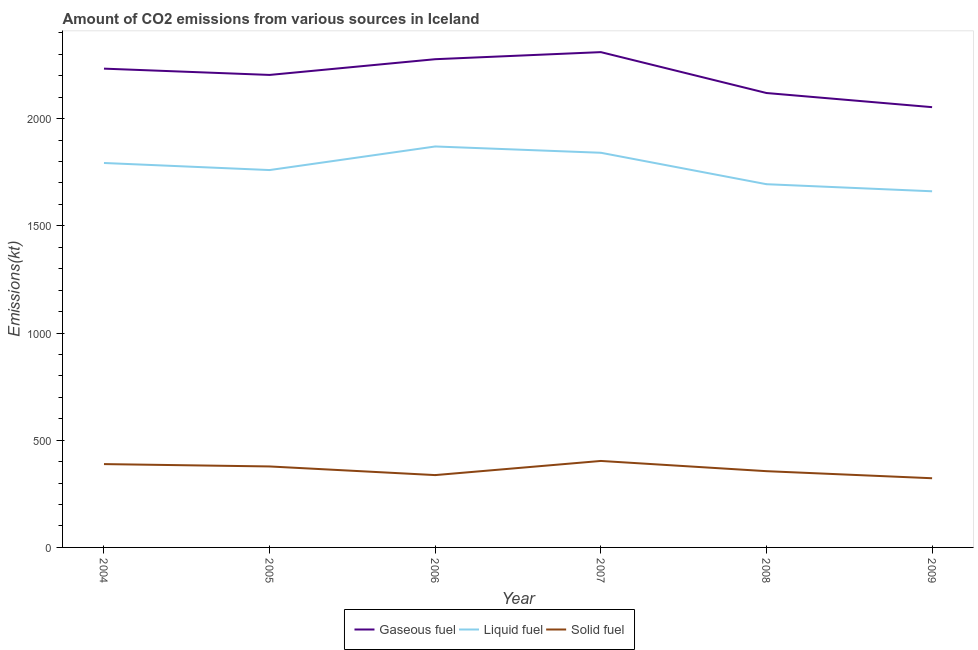What is the amount of co2 emissions from liquid fuel in 2004?
Keep it short and to the point. 1793.16. Across all years, what is the maximum amount of co2 emissions from solid fuel?
Provide a short and direct response. 403.37. Across all years, what is the minimum amount of co2 emissions from liquid fuel?
Ensure brevity in your answer.  1661.15. What is the total amount of co2 emissions from gaseous fuel in the graph?
Your response must be concise. 1.32e+04. What is the difference between the amount of co2 emissions from solid fuel in 2005 and that in 2007?
Keep it short and to the point. -25.67. What is the difference between the amount of co2 emissions from liquid fuel in 2007 and the amount of co2 emissions from gaseous fuel in 2006?
Keep it short and to the point. -436.37. What is the average amount of co2 emissions from solid fuel per year?
Your answer should be compact. 364.26. In the year 2005, what is the difference between the amount of co2 emissions from gaseous fuel and amount of co2 emissions from solid fuel?
Your answer should be compact. 1826.17. In how many years, is the amount of co2 emissions from solid fuel greater than 1600 kt?
Offer a terse response. 0. What is the ratio of the amount of co2 emissions from gaseous fuel in 2006 to that in 2009?
Provide a succinct answer. 1.11. Is the amount of co2 emissions from liquid fuel in 2005 less than that in 2009?
Your response must be concise. No. What is the difference between the highest and the second highest amount of co2 emissions from gaseous fuel?
Make the answer very short. 33. What is the difference between the highest and the lowest amount of co2 emissions from liquid fuel?
Provide a short and direct response. 209.02. In how many years, is the amount of co2 emissions from gaseous fuel greater than the average amount of co2 emissions from gaseous fuel taken over all years?
Your answer should be very brief. 4. Is it the case that in every year, the sum of the amount of co2 emissions from gaseous fuel and amount of co2 emissions from liquid fuel is greater than the amount of co2 emissions from solid fuel?
Provide a succinct answer. Yes. Is the amount of co2 emissions from liquid fuel strictly greater than the amount of co2 emissions from solid fuel over the years?
Offer a terse response. Yes. How many lines are there?
Keep it short and to the point. 3. How many years are there in the graph?
Keep it short and to the point. 6. What is the difference between two consecutive major ticks on the Y-axis?
Give a very brief answer. 500. Are the values on the major ticks of Y-axis written in scientific E-notation?
Give a very brief answer. No. Does the graph contain any zero values?
Keep it short and to the point. No. Where does the legend appear in the graph?
Keep it short and to the point. Bottom center. How many legend labels are there?
Your answer should be compact. 3. What is the title of the graph?
Ensure brevity in your answer.  Amount of CO2 emissions from various sources in Iceland. What is the label or title of the X-axis?
Your response must be concise. Year. What is the label or title of the Y-axis?
Keep it short and to the point. Emissions(kt). What is the Emissions(kt) of Gaseous fuel in 2004?
Give a very brief answer. 2233.2. What is the Emissions(kt) in Liquid fuel in 2004?
Your response must be concise. 1793.16. What is the Emissions(kt) in Solid fuel in 2004?
Make the answer very short. 388.7. What is the Emissions(kt) of Gaseous fuel in 2005?
Your answer should be very brief. 2203.87. What is the Emissions(kt) in Liquid fuel in 2005?
Your response must be concise. 1760.16. What is the Emissions(kt) in Solid fuel in 2005?
Give a very brief answer. 377.7. What is the Emissions(kt) of Gaseous fuel in 2006?
Make the answer very short. 2277.21. What is the Emissions(kt) of Liquid fuel in 2006?
Your response must be concise. 1870.17. What is the Emissions(kt) in Solid fuel in 2006?
Give a very brief answer. 337.36. What is the Emissions(kt) of Gaseous fuel in 2007?
Ensure brevity in your answer.  2310.21. What is the Emissions(kt) of Liquid fuel in 2007?
Give a very brief answer. 1840.83. What is the Emissions(kt) of Solid fuel in 2007?
Make the answer very short. 403.37. What is the Emissions(kt) of Gaseous fuel in 2008?
Your answer should be compact. 2119.53. What is the Emissions(kt) in Liquid fuel in 2008?
Provide a succinct answer. 1694.15. What is the Emissions(kt) in Solid fuel in 2008?
Ensure brevity in your answer.  355.7. What is the Emissions(kt) of Gaseous fuel in 2009?
Make the answer very short. 2053.52. What is the Emissions(kt) of Liquid fuel in 2009?
Offer a very short reply. 1661.15. What is the Emissions(kt) of Solid fuel in 2009?
Make the answer very short. 322.7. Across all years, what is the maximum Emissions(kt) in Gaseous fuel?
Your answer should be very brief. 2310.21. Across all years, what is the maximum Emissions(kt) in Liquid fuel?
Offer a terse response. 1870.17. Across all years, what is the maximum Emissions(kt) of Solid fuel?
Offer a very short reply. 403.37. Across all years, what is the minimum Emissions(kt) of Gaseous fuel?
Make the answer very short. 2053.52. Across all years, what is the minimum Emissions(kt) of Liquid fuel?
Your answer should be compact. 1661.15. Across all years, what is the minimum Emissions(kt) of Solid fuel?
Your answer should be compact. 322.7. What is the total Emissions(kt) in Gaseous fuel in the graph?
Offer a very short reply. 1.32e+04. What is the total Emissions(kt) of Liquid fuel in the graph?
Your response must be concise. 1.06e+04. What is the total Emissions(kt) in Solid fuel in the graph?
Your answer should be compact. 2185.53. What is the difference between the Emissions(kt) in Gaseous fuel in 2004 and that in 2005?
Ensure brevity in your answer.  29.34. What is the difference between the Emissions(kt) in Liquid fuel in 2004 and that in 2005?
Your answer should be very brief. 33. What is the difference between the Emissions(kt) of Solid fuel in 2004 and that in 2005?
Provide a short and direct response. 11. What is the difference between the Emissions(kt) of Gaseous fuel in 2004 and that in 2006?
Provide a succinct answer. -44. What is the difference between the Emissions(kt) in Liquid fuel in 2004 and that in 2006?
Your answer should be compact. -77.01. What is the difference between the Emissions(kt) of Solid fuel in 2004 and that in 2006?
Your answer should be very brief. 51.34. What is the difference between the Emissions(kt) in Gaseous fuel in 2004 and that in 2007?
Provide a succinct answer. -77.01. What is the difference between the Emissions(kt) in Liquid fuel in 2004 and that in 2007?
Provide a succinct answer. -47.67. What is the difference between the Emissions(kt) in Solid fuel in 2004 and that in 2007?
Your answer should be compact. -14.67. What is the difference between the Emissions(kt) in Gaseous fuel in 2004 and that in 2008?
Keep it short and to the point. 113.68. What is the difference between the Emissions(kt) in Liquid fuel in 2004 and that in 2008?
Give a very brief answer. 99.01. What is the difference between the Emissions(kt) in Solid fuel in 2004 and that in 2008?
Make the answer very short. 33. What is the difference between the Emissions(kt) of Gaseous fuel in 2004 and that in 2009?
Offer a very short reply. 179.68. What is the difference between the Emissions(kt) of Liquid fuel in 2004 and that in 2009?
Offer a very short reply. 132.01. What is the difference between the Emissions(kt) of Solid fuel in 2004 and that in 2009?
Keep it short and to the point. 66.01. What is the difference between the Emissions(kt) of Gaseous fuel in 2005 and that in 2006?
Your answer should be compact. -73.34. What is the difference between the Emissions(kt) in Liquid fuel in 2005 and that in 2006?
Offer a terse response. -110.01. What is the difference between the Emissions(kt) of Solid fuel in 2005 and that in 2006?
Your response must be concise. 40.34. What is the difference between the Emissions(kt) of Gaseous fuel in 2005 and that in 2007?
Offer a very short reply. -106.34. What is the difference between the Emissions(kt) of Liquid fuel in 2005 and that in 2007?
Your answer should be compact. -80.67. What is the difference between the Emissions(kt) in Solid fuel in 2005 and that in 2007?
Provide a succinct answer. -25.67. What is the difference between the Emissions(kt) of Gaseous fuel in 2005 and that in 2008?
Your response must be concise. 84.34. What is the difference between the Emissions(kt) in Liquid fuel in 2005 and that in 2008?
Ensure brevity in your answer.  66.01. What is the difference between the Emissions(kt) in Solid fuel in 2005 and that in 2008?
Your answer should be compact. 22. What is the difference between the Emissions(kt) of Gaseous fuel in 2005 and that in 2009?
Offer a terse response. 150.35. What is the difference between the Emissions(kt) of Liquid fuel in 2005 and that in 2009?
Offer a terse response. 99.01. What is the difference between the Emissions(kt) of Solid fuel in 2005 and that in 2009?
Offer a very short reply. 55.01. What is the difference between the Emissions(kt) of Gaseous fuel in 2006 and that in 2007?
Your answer should be very brief. -33. What is the difference between the Emissions(kt) of Liquid fuel in 2006 and that in 2007?
Your answer should be compact. 29.34. What is the difference between the Emissions(kt) of Solid fuel in 2006 and that in 2007?
Provide a succinct answer. -66.01. What is the difference between the Emissions(kt) of Gaseous fuel in 2006 and that in 2008?
Offer a terse response. 157.68. What is the difference between the Emissions(kt) in Liquid fuel in 2006 and that in 2008?
Provide a succinct answer. 176.02. What is the difference between the Emissions(kt) in Solid fuel in 2006 and that in 2008?
Provide a succinct answer. -18.34. What is the difference between the Emissions(kt) of Gaseous fuel in 2006 and that in 2009?
Offer a terse response. 223.69. What is the difference between the Emissions(kt) in Liquid fuel in 2006 and that in 2009?
Offer a terse response. 209.02. What is the difference between the Emissions(kt) in Solid fuel in 2006 and that in 2009?
Provide a succinct answer. 14.67. What is the difference between the Emissions(kt) in Gaseous fuel in 2007 and that in 2008?
Ensure brevity in your answer.  190.68. What is the difference between the Emissions(kt) of Liquid fuel in 2007 and that in 2008?
Your answer should be compact. 146.68. What is the difference between the Emissions(kt) in Solid fuel in 2007 and that in 2008?
Make the answer very short. 47.67. What is the difference between the Emissions(kt) in Gaseous fuel in 2007 and that in 2009?
Offer a terse response. 256.69. What is the difference between the Emissions(kt) of Liquid fuel in 2007 and that in 2009?
Provide a succinct answer. 179.68. What is the difference between the Emissions(kt) in Solid fuel in 2007 and that in 2009?
Make the answer very short. 80.67. What is the difference between the Emissions(kt) of Gaseous fuel in 2008 and that in 2009?
Your answer should be very brief. 66.01. What is the difference between the Emissions(kt) of Liquid fuel in 2008 and that in 2009?
Keep it short and to the point. 33. What is the difference between the Emissions(kt) in Solid fuel in 2008 and that in 2009?
Offer a very short reply. 33. What is the difference between the Emissions(kt) in Gaseous fuel in 2004 and the Emissions(kt) in Liquid fuel in 2005?
Ensure brevity in your answer.  473.04. What is the difference between the Emissions(kt) in Gaseous fuel in 2004 and the Emissions(kt) in Solid fuel in 2005?
Offer a terse response. 1855.5. What is the difference between the Emissions(kt) in Liquid fuel in 2004 and the Emissions(kt) in Solid fuel in 2005?
Provide a succinct answer. 1415.46. What is the difference between the Emissions(kt) of Gaseous fuel in 2004 and the Emissions(kt) of Liquid fuel in 2006?
Your answer should be very brief. 363.03. What is the difference between the Emissions(kt) in Gaseous fuel in 2004 and the Emissions(kt) in Solid fuel in 2006?
Your answer should be very brief. 1895.84. What is the difference between the Emissions(kt) in Liquid fuel in 2004 and the Emissions(kt) in Solid fuel in 2006?
Make the answer very short. 1455.8. What is the difference between the Emissions(kt) in Gaseous fuel in 2004 and the Emissions(kt) in Liquid fuel in 2007?
Keep it short and to the point. 392.37. What is the difference between the Emissions(kt) of Gaseous fuel in 2004 and the Emissions(kt) of Solid fuel in 2007?
Your answer should be compact. 1829.83. What is the difference between the Emissions(kt) in Liquid fuel in 2004 and the Emissions(kt) in Solid fuel in 2007?
Your response must be concise. 1389.79. What is the difference between the Emissions(kt) of Gaseous fuel in 2004 and the Emissions(kt) of Liquid fuel in 2008?
Your answer should be very brief. 539.05. What is the difference between the Emissions(kt) of Gaseous fuel in 2004 and the Emissions(kt) of Solid fuel in 2008?
Provide a succinct answer. 1877.5. What is the difference between the Emissions(kt) in Liquid fuel in 2004 and the Emissions(kt) in Solid fuel in 2008?
Offer a terse response. 1437.46. What is the difference between the Emissions(kt) in Gaseous fuel in 2004 and the Emissions(kt) in Liquid fuel in 2009?
Offer a very short reply. 572.05. What is the difference between the Emissions(kt) in Gaseous fuel in 2004 and the Emissions(kt) in Solid fuel in 2009?
Your response must be concise. 1910.51. What is the difference between the Emissions(kt) in Liquid fuel in 2004 and the Emissions(kt) in Solid fuel in 2009?
Offer a very short reply. 1470.47. What is the difference between the Emissions(kt) in Gaseous fuel in 2005 and the Emissions(kt) in Liquid fuel in 2006?
Your answer should be compact. 333.7. What is the difference between the Emissions(kt) of Gaseous fuel in 2005 and the Emissions(kt) of Solid fuel in 2006?
Give a very brief answer. 1866.5. What is the difference between the Emissions(kt) in Liquid fuel in 2005 and the Emissions(kt) in Solid fuel in 2006?
Your answer should be very brief. 1422.8. What is the difference between the Emissions(kt) of Gaseous fuel in 2005 and the Emissions(kt) of Liquid fuel in 2007?
Your response must be concise. 363.03. What is the difference between the Emissions(kt) of Gaseous fuel in 2005 and the Emissions(kt) of Solid fuel in 2007?
Provide a succinct answer. 1800.5. What is the difference between the Emissions(kt) in Liquid fuel in 2005 and the Emissions(kt) in Solid fuel in 2007?
Ensure brevity in your answer.  1356.79. What is the difference between the Emissions(kt) of Gaseous fuel in 2005 and the Emissions(kt) of Liquid fuel in 2008?
Your answer should be very brief. 509.71. What is the difference between the Emissions(kt) in Gaseous fuel in 2005 and the Emissions(kt) in Solid fuel in 2008?
Keep it short and to the point. 1848.17. What is the difference between the Emissions(kt) of Liquid fuel in 2005 and the Emissions(kt) of Solid fuel in 2008?
Your answer should be very brief. 1404.46. What is the difference between the Emissions(kt) of Gaseous fuel in 2005 and the Emissions(kt) of Liquid fuel in 2009?
Offer a terse response. 542.72. What is the difference between the Emissions(kt) of Gaseous fuel in 2005 and the Emissions(kt) of Solid fuel in 2009?
Ensure brevity in your answer.  1881.17. What is the difference between the Emissions(kt) in Liquid fuel in 2005 and the Emissions(kt) in Solid fuel in 2009?
Provide a short and direct response. 1437.46. What is the difference between the Emissions(kt) of Gaseous fuel in 2006 and the Emissions(kt) of Liquid fuel in 2007?
Offer a terse response. 436.37. What is the difference between the Emissions(kt) of Gaseous fuel in 2006 and the Emissions(kt) of Solid fuel in 2007?
Give a very brief answer. 1873.84. What is the difference between the Emissions(kt) in Liquid fuel in 2006 and the Emissions(kt) in Solid fuel in 2007?
Your response must be concise. 1466.8. What is the difference between the Emissions(kt) in Gaseous fuel in 2006 and the Emissions(kt) in Liquid fuel in 2008?
Give a very brief answer. 583.05. What is the difference between the Emissions(kt) of Gaseous fuel in 2006 and the Emissions(kt) of Solid fuel in 2008?
Give a very brief answer. 1921.51. What is the difference between the Emissions(kt) of Liquid fuel in 2006 and the Emissions(kt) of Solid fuel in 2008?
Your answer should be very brief. 1514.47. What is the difference between the Emissions(kt) in Gaseous fuel in 2006 and the Emissions(kt) in Liquid fuel in 2009?
Make the answer very short. 616.06. What is the difference between the Emissions(kt) in Gaseous fuel in 2006 and the Emissions(kt) in Solid fuel in 2009?
Your response must be concise. 1954.51. What is the difference between the Emissions(kt) in Liquid fuel in 2006 and the Emissions(kt) in Solid fuel in 2009?
Your answer should be compact. 1547.47. What is the difference between the Emissions(kt) in Gaseous fuel in 2007 and the Emissions(kt) in Liquid fuel in 2008?
Keep it short and to the point. 616.06. What is the difference between the Emissions(kt) in Gaseous fuel in 2007 and the Emissions(kt) in Solid fuel in 2008?
Provide a short and direct response. 1954.51. What is the difference between the Emissions(kt) in Liquid fuel in 2007 and the Emissions(kt) in Solid fuel in 2008?
Offer a very short reply. 1485.13. What is the difference between the Emissions(kt) of Gaseous fuel in 2007 and the Emissions(kt) of Liquid fuel in 2009?
Make the answer very short. 649.06. What is the difference between the Emissions(kt) in Gaseous fuel in 2007 and the Emissions(kt) in Solid fuel in 2009?
Provide a short and direct response. 1987.51. What is the difference between the Emissions(kt) in Liquid fuel in 2007 and the Emissions(kt) in Solid fuel in 2009?
Ensure brevity in your answer.  1518.14. What is the difference between the Emissions(kt) of Gaseous fuel in 2008 and the Emissions(kt) of Liquid fuel in 2009?
Provide a succinct answer. 458.38. What is the difference between the Emissions(kt) in Gaseous fuel in 2008 and the Emissions(kt) in Solid fuel in 2009?
Ensure brevity in your answer.  1796.83. What is the difference between the Emissions(kt) of Liquid fuel in 2008 and the Emissions(kt) of Solid fuel in 2009?
Your answer should be compact. 1371.46. What is the average Emissions(kt) in Gaseous fuel per year?
Your answer should be compact. 2199.59. What is the average Emissions(kt) of Liquid fuel per year?
Your answer should be very brief. 1769.94. What is the average Emissions(kt) in Solid fuel per year?
Offer a very short reply. 364.26. In the year 2004, what is the difference between the Emissions(kt) in Gaseous fuel and Emissions(kt) in Liquid fuel?
Make the answer very short. 440.04. In the year 2004, what is the difference between the Emissions(kt) in Gaseous fuel and Emissions(kt) in Solid fuel?
Your response must be concise. 1844.5. In the year 2004, what is the difference between the Emissions(kt) of Liquid fuel and Emissions(kt) of Solid fuel?
Give a very brief answer. 1404.46. In the year 2005, what is the difference between the Emissions(kt) of Gaseous fuel and Emissions(kt) of Liquid fuel?
Give a very brief answer. 443.71. In the year 2005, what is the difference between the Emissions(kt) in Gaseous fuel and Emissions(kt) in Solid fuel?
Your answer should be compact. 1826.17. In the year 2005, what is the difference between the Emissions(kt) of Liquid fuel and Emissions(kt) of Solid fuel?
Your answer should be compact. 1382.46. In the year 2006, what is the difference between the Emissions(kt) of Gaseous fuel and Emissions(kt) of Liquid fuel?
Make the answer very short. 407.04. In the year 2006, what is the difference between the Emissions(kt) of Gaseous fuel and Emissions(kt) of Solid fuel?
Your answer should be very brief. 1939.84. In the year 2006, what is the difference between the Emissions(kt) of Liquid fuel and Emissions(kt) of Solid fuel?
Give a very brief answer. 1532.81. In the year 2007, what is the difference between the Emissions(kt) in Gaseous fuel and Emissions(kt) in Liquid fuel?
Keep it short and to the point. 469.38. In the year 2007, what is the difference between the Emissions(kt) of Gaseous fuel and Emissions(kt) of Solid fuel?
Your answer should be very brief. 1906.84. In the year 2007, what is the difference between the Emissions(kt) of Liquid fuel and Emissions(kt) of Solid fuel?
Your response must be concise. 1437.46. In the year 2008, what is the difference between the Emissions(kt) in Gaseous fuel and Emissions(kt) in Liquid fuel?
Your answer should be very brief. 425.37. In the year 2008, what is the difference between the Emissions(kt) of Gaseous fuel and Emissions(kt) of Solid fuel?
Offer a terse response. 1763.83. In the year 2008, what is the difference between the Emissions(kt) of Liquid fuel and Emissions(kt) of Solid fuel?
Your response must be concise. 1338.45. In the year 2009, what is the difference between the Emissions(kt) of Gaseous fuel and Emissions(kt) of Liquid fuel?
Provide a succinct answer. 392.37. In the year 2009, what is the difference between the Emissions(kt) in Gaseous fuel and Emissions(kt) in Solid fuel?
Offer a terse response. 1730.82. In the year 2009, what is the difference between the Emissions(kt) of Liquid fuel and Emissions(kt) of Solid fuel?
Keep it short and to the point. 1338.45. What is the ratio of the Emissions(kt) in Gaseous fuel in 2004 to that in 2005?
Offer a very short reply. 1.01. What is the ratio of the Emissions(kt) in Liquid fuel in 2004 to that in 2005?
Offer a terse response. 1.02. What is the ratio of the Emissions(kt) of Solid fuel in 2004 to that in 2005?
Keep it short and to the point. 1.03. What is the ratio of the Emissions(kt) of Gaseous fuel in 2004 to that in 2006?
Your answer should be compact. 0.98. What is the ratio of the Emissions(kt) in Liquid fuel in 2004 to that in 2006?
Ensure brevity in your answer.  0.96. What is the ratio of the Emissions(kt) in Solid fuel in 2004 to that in 2006?
Ensure brevity in your answer.  1.15. What is the ratio of the Emissions(kt) in Gaseous fuel in 2004 to that in 2007?
Your answer should be compact. 0.97. What is the ratio of the Emissions(kt) in Liquid fuel in 2004 to that in 2007?
Your answer should be very brief. 0.97. What is the ratio of the Emissions(kt) of Solid fuel in 2004 to that in 2007?
Offer a very short reply. 0.96. What is the ratio of the Emissions(kt) in Gaseous fuel in 2004 to that in 2008?
Offer a terse response. 1.05. What is the ratio of the Emissions(kt) in Liquid fuel in 2004 to that in 2008?
Your answer should be compact. 1.06. What is the ratio of the Emissions(kt) in Solid fuel in 2004 to that in 2008?
Your answer should be compact. 1.09. What is the ratio of the Emissions(kt) of Gaseous fuel in 2004 to that in 2009?
Offer a very short reply. 1.09. What is the ratio of the Emissions(kt) of Liquid fuel in 2004 to that in 2009?
Offer a very short reply. 1.08. What is the ratio of the Emissions(kt) of Solid fuel in 2004 to that in 2009?
Provide a succinct answer. 1.2. What is the ratio of the Emissions(kt) of Gaseous fuel in 2005 to that in 2006?
Offer a terse response. 0.97. What is the ratio of the Emissions(kt) in Liquid fuel in 2005 to that in 2006?
Your response must be concise. 0.94. What is the ratio of the Emissions(kt) of Solid fuel in 2005 to that in 2006?
Provide a succinct answer. 1.12. What is the ratio of the Emissions(kt) of Gaseous fuel in 2005 to that in 2007?
Your answer should be very brief. 0.95. What is the ratio of the Emissions(kt) in Liquid fuel in 2005 to that in 2007?
Keep it short and to the point. 0.96. What is the ratio of the Emissions(kt) in Solid fuel in 2005 to that in 2007?
Ensure brevity in your answer.  0.94. What is the ratio of the Emissions(kt) in Gaseous fuel in 2005 to that in 2008?
Ensure brevity in your answer.  1.04. What is the ratio of the Emissions(kt) in Liquid fuel in 2005 to that in 2008?
Offer a terse response. 1.04. What is the ratio of the Emissions(kt) of Solid fuel in 2005 to that in 2008?
Provide a short and direct response. 1.06. What is the ratio of the Emissions(kt) of Gaseous fuel in 2005 to that in 2009?
Offer a terse response. 1.07. What is the ratio of the Emissions(kt) in Liquid fuel in 2005 to that in 2009?
Your answer should be very brief. 1.06. What is the ratio of the Emissions(kt) in Solid fuel in 2005 to that in 2009?
Provide a short and direct response. 1.17. What is the ratio of the Emissions(kt) in Gaseous fuel in 2006 to that in 2007?
Provide a short and direct response. 0.99. What is the ratio of the Emissions(kt) in Liquid fuel in 2006 to that in 2007?
Provide a succinct answer. 1.02. What is the ratio of the Emissions(kt) of Solid fuel in 2006 to that in 2007?
Ensure brevity in your answer.  0.84. What is the ratio of the Emissions(kt) of Gaseous fuel in 2006 to that in 2008?
Keep it short and to the point. 1.07. What is the ratio of the Emissions(kt) of Liquid fuel in 2006 to that in 2008?
Your response must be concise. 1.1. What is the ratio of the Emissions(kt) of Solid fuel in 2006 to that in 2008?
Your answer should be compact. 0.95. What is the ratio of the Emissions(kt) in Gaseous fuel in 2006 to that in 2009?
Make the answer very short. 1.11. What is the ratio of the Emissions(kt) of Liquid fuel in 2006 to that in 2009?
Provide a succinct answer. 1.13. What is the ratio of the Emissions(kt) in Solid fuel in 2006 to that in 2009?
Provide a succinct answer. 1.05. What is the ratio of the Emissions(kt) in Gaseous fuel in 2007 to that in 2008?
Your answer should be very brief. 1.09. What is the ratio of the Emissions(kt) of Liquid fuel in 2007 to that in 2008?
Your answer should be compact. 1.09. What is the ratio of the Emissions(kt) of Solid fuel in 2007 to that in 2008?
Your answer should be very brief. 1.13. What is the ratio of the Emissions(kt) of Liquid fuel in 2007 to that in 2009?
Your response must be concise. 1.11. What is the ratio of the Emissions(kt) of Solid fuel in 2007 to that in 2009?
Offer a very short reply. 1.25. What is the ratio of the Emissions(kt) of Gaseous fuel in 2008 to that in 2009?
Provide a short and direct response. 1.03. What is the ratio of the Emissions(kt) in Liquid fuel in 2008 to that in 2009?
Your response must be concise. 1.02. What is the ratio of the Emissions(kt) in Solid fuel in 2008 to that in 2009?
Your answer should be compact. 1.1. What is the difference between the highest and the second highest Emissions(kt) in Gaseous fuel?
Your answer should be compact. 33. What is the difference between the highest and the second highest Emissions(kt) in Liquid fuel?
Offer a very short reply. 29.34. What is the difference between the highest and the second highest Emissions(kt) in Solid fuel?
Provide a succinct answer. 14.67. What is the difference between the highest and the lowest Emissions(kt) of Gaseous fuel?
Offer a very short reply. 256.69. What is the difference between the highest and the lowest Emissions(kt) in Liquid fuel?
Your answer should be very brief. 209.02. What is the difference between the highest and the lowest Emissions(kt) in Solid fuel?
Keep it short and to the point. 80.67. 